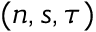Convert formula to latex. <formula><loc_0><loc_0><loc_500><loc_500>( n , s , \tau )</formula> 